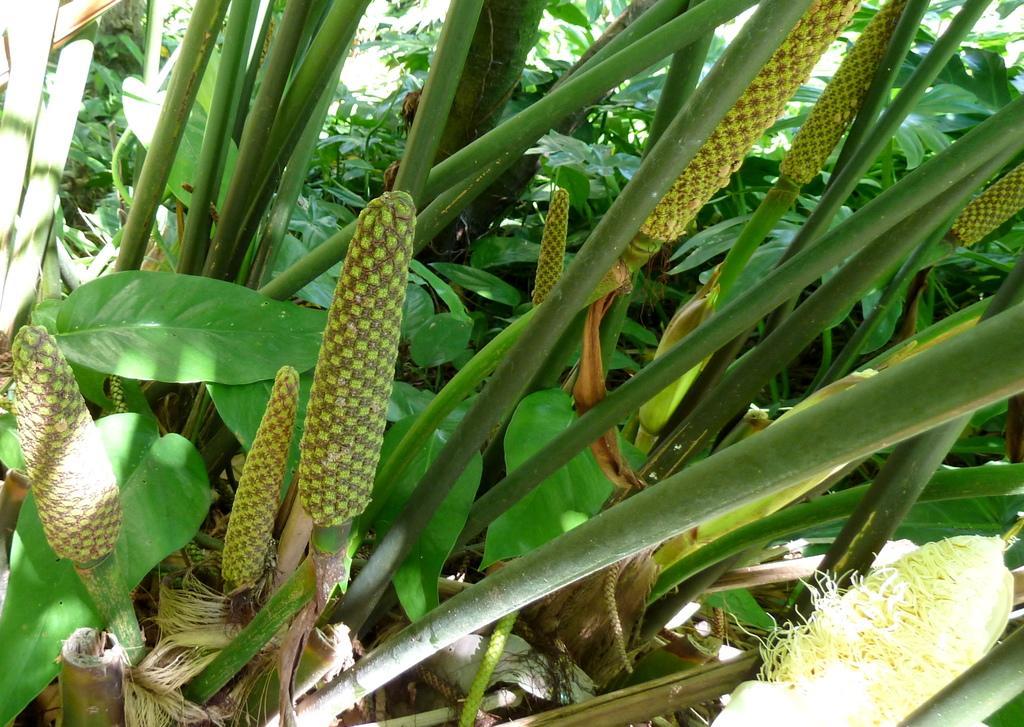Please provide a concise description of this image. In the foreground of this picture, there are corn trees and we can also see few corns to it. The background is greenery. 